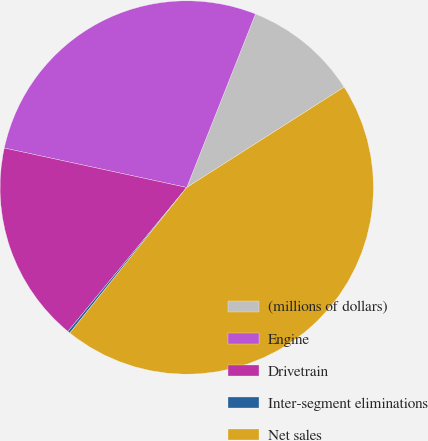Convert chart to OTSL. <chart><loc_0><loc_0><loc_500><loc_500><pie_chart><fcel>(millions of dollars)<fcel>Engine<fcel>Drivetrain<fcel>Inter-segment eliminations<fcel>Net sales<nl><fcel>9.96%<fcel>27.61%<fcel>17.41%<fcel>0.21%<fcel>44.81%<nl></chart> 